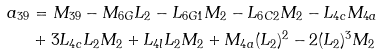<formula> <loc_0><loc_0><loc_500><loc_500>a _ { 3 9 } & = M _ { 3 9 } - M _ { 6 G } L _ { 2 } - L _ { 6 G 1 } M _ { 2 } - L _ { 6 C 2 } M _ { 2 } - L _ { 4 c } M _ { 4 a } \\ & + 3 L _ { 4 c } L _ { 2 } M _ { 2 } + L _ { 4 l } L _ { 2 } M _ { 2 } + M _ { 4 a } ( L _ { 2 } ) ^ { 2 } - 2 ( L _ { 2 } ) ^ { 3 } M _ { 2 }</formula> 